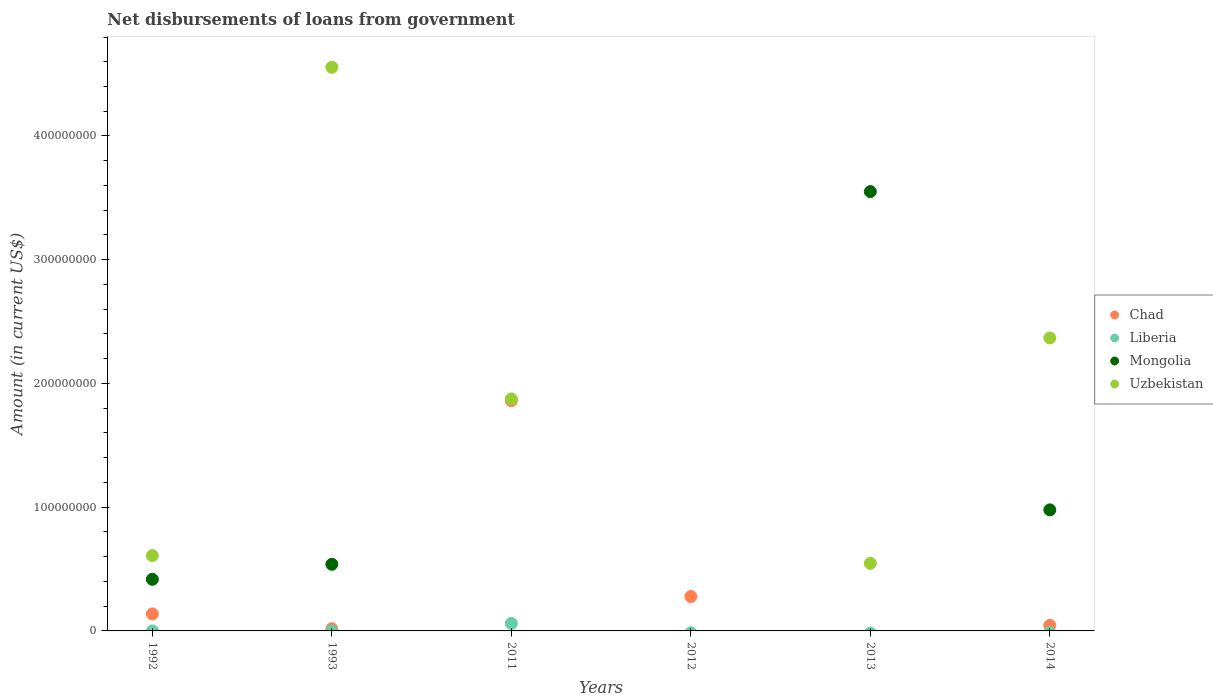Is the number of dotlines equal to the number of legend labels?
Offer a terse response. No. What is the amount of loan disbursed from government in Liberia in 2014?
Your response must be concise. 0. Across all years, what is the maximum amount of loan disbursed from government in Uzbekistan?
Ensure brevity in your answer.  4.56e+08. In which year was the amount of loan disbursed from government in Chad maximum?
Your answer should be compact. 2011. What is the total amount of loan disbursed from government in Uzbekistan in the graph?
Offer a terse response. 9.95e+08. What is the difference between the amount of loan disbursed from government in Uzbekistan in 1993 and that in 2014?
Your answer should be compact. 2.19e+08. What is the difference between the amount of loan disbursed from government in Chad in 1993 and the amount of loan disbursed from government in Liberia in 2013?
Provide a succinct answer. 1.79e+06. What is the average amount of loan disbursed from government in Chad per year?
Offer a very short reply. 3.90e+07. In the year 2013, what is the difference between the amount of loan disbursed from government in Mongolia and amount of loan disbursed from government in Uzbekistan?
Provide a short and direct response. 3.00e+08. What is the ratio of the amount of loan disbursed from government in Uzbekistan in 1993 to that in 2011?
Ensure brevity in your answer.  2.43. What is the difference between the highest and the second highest amount of loan disbursed from government in Mongolia?
Ensure brevity in your answer.  2.57e+08. What is the difference between the highest and the lowest amount of loan disbursed from government in Chad?
Make the answer very short. 1.86e+08. Is the sum of the amount of loan disbursed from government in Uzbekistan in 1992 and 1993 greater than the maximum amount of loan disbursed from government in Chad across all years?
Offer a terse response. Yes. Is it the case that in every year, the sum of the amount of loan disbursed from government in Liberia and amount of loan disbursed from government in Mongolia  is greater than the sum of amount of loan disbursed from government in Chad and amount of loan disbursed from government in Uzbekistan?
Give a very brief answer. No. Is it the case that in every year, the sum of the amount of loan disbursed from government in Chad and amount of loan disbursed from government in Uzbekistan  is greater than the amount of loan disbursed from government in Liberia?
Provide a succinct answer. Yes. Does the amount of loan disbursed from government in Mongolia monotonically increase over the years?
Offer a terse response. No. What is the difference between two consecutive major ticks on the Y-axis?
Make the answer very short. 1.00e+08. Does the graph contain grids?
Keep it short and to the point. No. Where does the legend appear in the graph?
Ensure brevity in your answer.  Center right. How many legend labels are there?
Make the answer very short. 4. How are the legend labels stacked?
Your response must be concise. Vertical. What is the title of the graph?
Make the answer very short. Net disbursements of loans from government. Does "Micronesia" appear as one of the legend labels in the graph?
Make the answer very short. No. What is the label or title of the Y-axis?
Provide a short and direct response. Amount (in current US$). What is the Amount (in current US$) of Chad in 1992?
Your answer should be very brief. 1.37e+07. What is the Amount (in current US$) of Liberia in 1992?
Your answer should be very brief. 2.70e+04. What is the Amount (in current US$) of Mongolia in 1992?
Ensure brevity in your answer.  4.17e+07. What is the Amount (in current US$) of Uzbekistan in 1992?
Ensure brevity in your answer.  6.09e+07. What is the Amount (in current US$) of Chad in 1993?
Your response must be concise. 1.79e+06. What is the Amount (in current US$) of Liberia in 1993?
Your response must be concise. 2.50e+04. What is the Amount (in current US$) in Mongolia in 1993?
Give a very brief answer. 5.38e+07. What is the Amount (in current US$) in Uzbekistan in 1993?
Offer a terse response. 4.56e+08. What is the Amount (in current US$) in Chad in 2011?
Keep it short and to the point. 1.86e+08. What is the Amount (in current US$) in Liberia in 2011?
Your answer should be very brief. 6.04e+06. What is the Amount (in current US$) of Mongolia in 2011?
Keep it short and to the point. 0. What is the Amount (in current US$) of Uzbekistan in 2011?
Provide a succinct answer. 1.87e+08. What is the Amount (in current US$) in Chad in 2012?
Ensure brevity in your answer.  2.78e+07. What is the Amount (in current US$) of Liberia in 2012?
Your answer should be very brief. 0. What is the Amount (in current US$) of Chad in 2013?
Provide a short and direct response. 0. What is the Amount (in current US$) in Liberia in 2013?
Make the answer very short. 0. What is the Amount (in current US$) of Mongolia in 2013?
Offer a terse response. 3.55e+08. What is the Amount (in current US$) of Uzbekistan in 2013?
Keep it short and to the point. 5.46e+07. What is the Amount (in current US$) of Chad in 2014?
Keep it short and to the point. 4.46e+06. What is the Amount (in current US$) in Mongolia in 2014?
Your answer should be compact. 9.79e+07. What is the Amount (in current US$) of Uzbekistan in 2014?
Give a very brief answer. 2.37e+08. Across all years, what is the maximum Amount (in current US$) of Chad?
Offer a very short reply. 1.86e+08. Across all years, what is the maximum Amount (in current US$) in Liberia?
Ensure brevity in your answer.  6.04e+06. Across all years, what is the maximum Amount (in current US$) in Mongolia?
Provide a succinct answer. 3.55e+08. Across all years, what is the maximum Amount (in current US$) in Uzbekistan?
Offer a terse response. 4.56e+08. Across all years, what is the minimum Amount (in current US$) of Chad?
Offer a terse response. 0. Across all years, what is the minimum Amount (in current US$) in Mongolia?
Your answer should be very brief. 0. Across all years, what is the minimum Amount (in current US$) of Uzbekistan?
Your response must be concise. 0. What is the total Amount (in current US$) in Chad in the graph?
Provide a short and direct response. 2.34e+08. What is the total Amount (in current US$) in Liberia in the graph?
Provide a succinct answer. 6.09e+06. What is the total Amount (in current US$) in Mongolia in the graph?
Your response must be concise. 5.48e+08. What is the total Amount (in current US$) of Uzbekistan in the graph?
Your answer should be compact. 9.95e+08. What is the difference between the Amount (in current US$) of Chad in 1992 and that in 1993?
Ensure brevity in your answer.  1.20e+07. What is the difference between the Amount (in current US$) in Liberia in 1992 and that in 1993?
Offer a terse response. 2000. What is the difference between the Amount (in current US$) in Mongolia in 1992 and that in 1993?
Your answer should be compact. -1.21e+07. What is the difference between the Amount (in current US$) of Uzbekistan in 1992 and that in 1993?
Offer a terse response. -3.95e+08. What is the difference between the Amount (in current US$) of Chad in 1992 and that in 2011?
Ensure brevity in your answer.  -1.72e+08. What is the difference between the Amount (in current US$) of Liberia in 1992 and that in 2011?
Ensure brevity in your answer.  -6.01e+06. What is the difference between the Amount (in current US$) of Uzbekistan in 1992 and that in 2011?
Your answer should be compact. -1.27e+08. What is the difference between the Amount (in current US$) of Chad in 1992 and that in 2012?
Provide a short and direct response. -1.40e+07. What is the difference between the Amount (in current US$) of Mongolia in 1992 and that in 2013?
Your answer should be very brief. -3.13e+08. What is the difference between the Amount (in current US$) in Uzbekistan in 1992 and that in 2013?
Make the answer very short. 6.28e+06. What is the difference between the Amount (in current US$) of Chad in 1992 and that in 2014?
Your answer should be very brief. 9.28e+06. What is the difference between the Amount (in current US$) of Mongolia in 1992 and that in 2014?
Offer a terse response. -5.61e+07. What is the difference between the Amount (in current US$) in Uzbekistan in 1992 and that in 2014?
Make the answer very short. -1.76e+08. What is the difference between the Amount (in current US$) of Chad in 1993 and that in 2011?
Offer a terse response. -1.84e+08. What is the difference between the Amount (in current US$) in Liberia in 1993 and that in 2011?
Keep it short and to the point. -6.02e+06. What is the difference between the Amount (in current US$) of Uzbekistan in 1993 and that in 2011?
Your response must be concise. 2.68e+08. What is the difference between the Amount (in current US$) of Chad in 1993 and that in 2012?
Make the answer very short. -2.60e+07. What is the difference between the Amount (in current US$) in Mongolia in 1993 and that in 2013?
Ensure brevity in your answer.  -3.01e+08. What is the difference between the Amount (in current US$) in Uzbekistan in 1993 and that in 2013?
Provide a succinct answer. 4.01e+08. What is the difference between the Amount (in current US$) in Chad in 1993 and that in 2014?
Offer a very short reply. -2.68e+06. What is the difference between the Amount (in current US$) of Mongolia in 1993 and that in 2014?
Give a very brief answer. -4.40e+07. What is the difference between the Amount (in current US$) in Uzbekistan in 1993 and that in 2014?
Provide a short and direct response. 2.19e+08. What is the difference between the Amount (in current US$) in Chad in 2011 and that in 2012?
Make the answer very short. 1.58e+08. What is the difference between the Amount (in current US$) of Uzbekistan in 2011 and that in 2013?
Make the answer very short. 1.33e+08. What is the difference between the Amount (in current US$) of Chad in 2011 and that in 2014?
Offer a very short reply. 1.82e+08. What is the difference between the Amount (in current US$) in Uzbekistan in 2011 and that in 2014?
Ensure brevity in your answer.  -4.93e+07. What is the difference between the Amount (in current US$) of Chad in 2012 and that in 2014?
Your answer should be very brief. 2.33e+07. What is the difference between the Amount (in current US$) in Mongolia in 2013 and that in 2014?
Ensure brevity in your answer.  2.57e+08. What is the difference between the Amount (in current US$) of Uzbekistan in 2013 and that in 2014?
Offer a terse response. -1.82e+08. What is the difference between the Amount (in current US$) in Chad in 1992 and the Amount (in current US$) in Liberia in 1993?
Offer a very short reply. 1.37e+07. What is the difference between the Amount (in current US$) of Chad in 1992 and the Amount (in current US$) of Mongolia in 1993?
Give a very brief answer. -4.01e+07. What is the difference between the Amount (in current US$) in Chad in 1992 and the Amount (in current US$) in Uzbekistan in 1993?
Provide a short and direct response. -4.42e+08. What is the difference between the Amount (in current US$) in Liberia in 1992 and the Amount (in current US$) in Mongolia in 1993?
Offer a terse response. -5.38e+07. What is the difference between the Amount (in current US$) of Liberia in 1992 and the Amount (in current US$) of Uzbekistan in 1993?
Keep it short and to the point. -4.56e+08. What is the difference between the Amount (in current US$) of Mongolia in 1992 and the Amount (in current US$) of Uzbekistan in 1993?
Your answer should be compact. -4.14e+08. What is the difference between the Amount (in current US$) of Chad in 1992 and the Amount (in current US$) of Liberia in 2011?
Offer a very short reply. 7.71e+06. What is the difference between the Amount (in current US$) in Chad in 1992 and the Amount (in current US$) in Uzbekistan in 2011?
Your response must be concise. -1.74e+08. What is the difference between the Amount (in current US$) in Liberia in 1992 and the Amount (in current US$) in Uzbekistan in 2011?
Your answer should be very brief. -1.87e+08. What is the difference between the Amount (in current US$) of Mongolia in 1992 and the Amount (in current US$) of Uzbekistan in 2011?
Keep it short and to the point. -1.46e+08. What is the difference between the Amount (in current US$) in Chad in 1992 and the Amount (in current US$) in Mongolia in 2013?
Your answer should be very brief. -3.41e+08. What is the difference between the Amount (in current US$) of Chad in 1992 and the Amount (in current US$) of Uzbekistan in 2013?
Your answer should be compact. -4.09e+07. What is the difference between the Amount (in current US$) in Liberia in 1992 and the Amount (in current US$) in Mongolia in 2013?
Your answer should be very brief. -3.55e+08. What is the difference between the Amount (in current US$) in Liberia in 1992 and the Amount (in current US$) in Uzbekistan in 2013?
Your answer should be very brief. -5.46e+07. What is the difference between the Amount (in current US$) of Mongolia in 1992 and the Amount (in current US$) of Uzbekistan in 2013?
Make the answer very short. -1.29e+07. What is the difference between the Amount (in current US$) in Chad in 1992 and the Amount (in current US$) in Mongolia in 2014?
Offer a very short reply. -8.41e+07. What is the difference between the Amount (in current US$) in Chad in 1992 and the Amount (in current US$) in Uzbekistan in 2014?
Provide a short and direct response. -2.23e+08. What is the difference between the Amount (in current US$) of Liberia in 1992 and the Amount (in current US$) of Mongolia in 2014?
Ensure brevity in your answer.  -9.78e+07. What is the difference between the Amount (in current US$) in Liberia in 1992 and the Amount (in current US$) in Uzbekistan in 2014?
Keep it short and to the point. -2.37e+08. What is the difference between the Amount (in current US$) in Mongolia in 1992 and the Amount (in current US$) in Uzbekistan in 2014?
Your response must be concise. -1.95e+08. What is the difference between the Amount (in current US$) in Chad in 1993 and the Amount (in current US$) in Liberia in 2011?
Provide a succinct answer. -4.25e+06. What is the difference between the Amount (in current US$) of Chad in 1993 and the Amount (in current US$) of Uzbekistan in 2011?
Ensure brevity in your answer.  -1.86e+08. What is the difference between the Amount (in current US$) of Liberia in 1993 and the Amount (in current US$) of Uzbekistan in 2011?
Your response must be concise. -1.87e+08. What is the difference between the Amount (in current US$) in Mongolia in 1993 and the Amount (in current US$) in Uzbekistan in 2011?
Offer a terse response. -1.34e+08. What is the difference between the Amount (in current US$) in Chad in 1993 and the Amount (in current US$) in Mongolia in 2013?
Provide a succinct answer. -3.53e+08. What is the difference between the Amount (in current US$) in Chad in 1993 and the Amount (in current US$) in Uzbekistan in 2013?
Ensure brevity in your answer.  -5.28e+07. What is the difference between the Amount (in current US$) of Liberia in 1993 and the Amount (in current US$) of Mongolia in 2013?
Offer a very short reply. -3.55e+08. What is the difference between the Amount (in current US$) of Liberia in 1993 and the Amount (in current US$) of Uzbekistan in 2013?
Your answer should be very brief. -5.46e+07. What is the difference between the Amount (in current US$) of Mongolia in 1993 and the Amount (in current US$) of Uzbekistan in 2013?
Keep it short and to the point. -7.75e+05. What is the difference between the Amount (in current US$) of Chad in 1993 and the Amount (in current US$) of Mongolia in 2014?
Give a very brief answer. -9.61e+07. What is the difference between the Amount (in current US$) of Chad in 1993 and the Amount (in current US$) of Uzbekistan in 2014?
Your answer should be very brief. -2.35e+08. What is the difference between the Amount (in current US$) in Liberia in 1993 and the Amount (in current US$) in Mongolia in 2014?
Offer a terse response. -9.78e+07. What is the difference between the Amount (in current US$) in Liberia in 1993 and the Amount (in current US$) in Uzbekistan in 2014?
Give a very brief answer. -2.37e+08. What is the difference between the Amount (in current US$) of Mongolia in 1993 and the Amount (in current US$) of Uzbekistan in 2014?
Make the answer very short. -1.83e+08. What is the difference between the Amount (in current US$) of Chad in 2011 and the Amount (in current US$) of Mongolia in 2013?
Your answer should be compact. -1.69e+08. What is the difference between the Amount (in current US$) of Chad in 2011 and the Amount (in current US$) of Uzbekistan in 2013?
Provide a succinct answer. 1.31e+08. What is the difference between the Amount (in current US$) of Liberia in 2011 and the Amount (in current US$) of Mongolia in 2013?
Your answer should be compact. -3.49e+08. What is the difference between the Amount (in current US$) in Liberia in 2011 and the Amount (in current US$) in Uzbekistan in 2013?
Ensure brevity in your answer.  -4.86e+07. What is the difference between the Amount (in current US$) of Chad in 2011 and the Amount (in current US$) of Mongolia in 2014?
Ensure brevity in your answer.  8.82e+07. What is the difference between the Amount (in current US$) in Chad in 2011 and the Amount (in current US$) in Uzbekistan in 2014?
Give a very brief answer. -5.08e+07. What is the difference between the Amount (in current US$) of Liberia in 2011 and the Amount (in current US$) of Mongolia in 2014?
Your answer should be very brief. -9.18e+07. What is the difference between the Amount (in current US$) of Liberia in 2011 and the Amount (in current US$) of Uzbekistan in 2014?
Make the answer very short. -2.31e+08. What is the difference between the Amount (in current US$) of Chad in 2012 and the Amount (in current US$) of Mongolia in 2013?
Your response must be concise. -3.27e+08. What is the difference between the Amount (in current US$) of Chad in 2012 and the Amount (in current US$) of Uzbekistan in 2013?
Provide a short and direct response. -2.68e+07. What is the difference between the Amount (in current US$) in Chad in 2012 and the Amount (in current US$) in Mongolia in 2014?
Keep it short and to the point. -7.01e+07. What is the difference between the Amount (in current US$) in Chad in 2012 and the Amount (in current US$) in Uzbekistan in 2014?
Your answer should be very brief. -2.09e+08. What is the difference between the Amount (in current US$) in Mongolia in 2013 and the Amount (in current US$) in Uzbekistan in 2014?
Your answer should be compact. 1.18e+08. What is the average Amount (in current US$) in Chad per year?
Keep it short and to the point. 3.90e+07. What is the average Amount (in current US$) in Liberia per year?
Ensure brevity in your answer.  1.02e+06. What is the average Amount (in current US$) of Mongolia per year?
Keep it short and to the point. 9.14e+07. What is the average Amount (in current US$) of Uzbekistan per year?
Keep it short and to the point. 1.66e+08. In the year 1992, what is the difference between the Amount (in current US$) in Chad and Amount (in current US$) in Liberia?
Offer a very short reply. 1.37e+07. In the year 1992, what is the difference between the Amount (in current US$) of Chad and Amount (in current US$) of Mongolia?
Your response must be concise. -2.80e+07. In the year 1992, what is the difference between the Amount (in current US$) in Chad and Amount (in current US$) in Uzbekistan?
Ensure brevity in your answer.  -4.71e+07. In the year 1992, what is the difference between the Amount (in current US$) in Liberia and Amount (in current US$) in Mongolia?
Give a very brief answer. -4.17e+07. In the year 1992, what is the difference between the Amount (in current US$) in Liberia and Amount (in current US$) in Uzbekistan?
Keep it short and to the point. -6.09e+07. In the year 1992, what is the difference between the Amount (in current US$) of Mongolia and Amount (in current US$) of Uzbekistan?
Provide a short and direct response. -1.92e+07. In the year 1993, what is the difference between the Amount (in current US$) in Chad and Amount (in current US$) in Liberia?
Your response must be concise. 1.76e+06. In the year 1993, what is the difference between the Amount (in current US$) of Chad and Amount (in current US$) of Mongolia?
Keep it short and to the point. -5.21e+07. In the year 1993, what is the difference between the Amount (in current US$) in Chad and Amount (in current US$) in Uzbekistan?
Keep it short and to the point. -4.54e+08. In the year 1993, what is the difference between the Amount (in current US$) in Liberia and Amount (in current US$) in Mongolia?
Your answer should be compact. -5.38e+07. In the year 1993, what is the difference between the Amount (in current US$) of Liberia and Amount (in current US$) of Uzbekistan?
Ensure brevity in your answer.  -4.56e+08. In the year 1993, what is the difference between the Amount (in current US$) of Mongolia and Amount (in current US$) of Uzbekistan?
Give a very brief answer. -4.02e+08. In the year 2011, what is the difference between the Amount (in current US$) of Chad and Amount (in current US$) of Liberia?
Ensure brevity in your answer.  1.80e+08. In the year 2011, what is the difference between the Amount (in current US$) in Chad and Amount (in current US$) in Uzbekistan?
Offer a very short reply. -1.42e+06. In the year 2011, what is the difference between the Amount (in current US$) in Liberia and Amount (in current US$) in Uzbekistan?
Offer a very short reply. -1.81e+08. In the year 2013, what is the difference between the Amount (in current US$) in Mongolia and Amount (in current US$) in Uzbekistan?
Your answer should be very brief. 3.00e+08. In the year 2014, what is the difference between the Amount (in current US$) of Chad and Amount (in current US$) of Mongolia?
Keep it short and to the point. -9.34e+07. In the year 2014, what is the difference between the Amount (in current US$) in Chad and Amount (in current US$) in Uzbekistan?
Ensure brevity in your answer.  -2.32e+08. In the year 2014, what is the difference between the Amount (in current US$) in Mongolia and Amount (in current US$) in Uzbekistan?
Your response must be concise. -1.39e+08. What is the ratio of the Amount (in current US$) in Chad in 1992 to that in 1993?
Provide a succinct answer. 7.69. What is the ratio of the Amount (in current US$) in Liberia in 1992 to that in 1993?
Your answer should be very brief. 1.08. What is the ratio of the Amount (in current US$) of Mongolia in 1992 to that in 1993?
Make the answer very short. 0.77. What is the ratio of the Amount (in current US$) of Uzbekistan in 1992 to that in 1993?
Your response must be concise. 0.13. What is the ratio of the Amount (in current US$) in Chad in 1992 to that in 2011?
Your response must be concise. 0.07. What is the ratio of the Amount (in current US$) of Liberia in 1992 to that in 2011?
Your answer should be very brief. 0. What is the ratio of the Amount (in current US$) of Uzbekistan in 1992 to that in 2011?
Provide a short and direct response. 0.32. What is the ratio of the Amount (in current US$) in Chad in 1992 to that in 2012?
Give a very brief answer. 0.49. What is the ratio of the Amount (in current US$) in Mongolia in 1992 to that in 2013?
Keep it short and to the point. 0.12. What is the ratio of the Amount (in current US$) in Uzbekistan in 1992 to that in 2013?
Offer a very short reply. 1.11. What is the ratio of the Amount (in current US$) of Chad in 1992 to that in 2014?
Provide a succinct answer. 3.08. What is the ratio of the Amount (in current US$) of Mongolia in 1992 to that in 2014?
Provide a short and direct response. 0.43. What is the ratio of the Amount (in current US$) of Uzbekistan in 1992 to that in 2014?
Provide a short and direct response. 0.26. What is the ratio of the Amount (in current US$) in Chad in 1993 to that in 2011?
Your answer should be very brief. 0.01. What is the ratio of the Amount (in current US$) in Liberia in 1993 to that in 2011?
Keep it short and to the point. 0. What is the ratio of the Amount (in current US$) of Uzbekistan in 1993 to that in 2011?
Give a very brief answer. 2.43. What is the ratio of the Amount (in current US$) in Chad in 1993 to that in 2012?
Make the answer very short. 0.06. What is the ratio of the Amount (in current US$) of Mongolia in 1993 to that in 2013?
Offer a very short reply. 0.15. What is the ratio of the Amount (in current US$) in Uzbekistan in 1993 to that in 2013?
Give a very brief answer. 8.34. What is the ratio of the Amount (in current US$) in Chad in 1993 to that in 2014?
Ensure brevity in your answer.  0.4. What is the ratio of the Amount (in current US$) of Mongolia in 1993 to that in 2014?
Your response must be concise. 0.55. What is the ratio of the Amount (in current US$) in Uzbekistan in 1993 to that in 2014?
Your answer should be very brief. 1.92. What is the ratio of the Amount (in current US$) of Chad in 2011 to that in 2012?
Provide a succinct answer. 6.69. What is the ratio of the Amount (in current US$) in Uzbekistan in 2011 to that in 2013?
Make the answer very short. 3.43. What is the ratio of the Amount (in current US$) of Chad in 2011 to that in 2014?
Your answer should be very brief. 41.67. What is the ratio of the Amount (in current US$) of Uzbekistan in 2011 to that in 2014?
Ensure brevity in your answer.  0.79. What is the ratio of the Amount (in current US$) of Chad in 2012 to that in 2014?
Your answer should be very brief. 6.22. What is the ratio of the Amount (in current US$) of Mongolia in 2013 to that in 2014?
Provide a succinct answer. 3.63. What is the ratio of the Amount (in current US$) in Uzbekistan in 2013 to that in 2014?
Your answer should be very brief. 0.23. What is the difference between the highest and the second highest Amount (in current US$) of Chad?
Provide a short and direct response. 1.58e+08. What is the difference between the highest and the second highest Amount (in current US$) in Liberia?
Give a very brief answer. 6.01e+06. What is the difference between the highest and the second highest Amount (in current US$) of Mongolia?
Offer a very short reply. 2.57e+08. What is the difference between the highest and the second highest Amount (in current US$) in Uzbekistan?
Offer a very short reply. 2.19e+08. What is the difference between the highest and the lowest Amount (in current US$) in Chad?
Provide a succinct answer. 1.86e+08. What is the difference between the highest and the lowest Amount (in current US$) in Liberia?
Offer a terse response. 6.04e+06. What is the difference between the highest and the lowest Amount (in current US$) of Mongolia?
Offer a terse response. 3.55e+08. What is the difference between the highest and the lowest Amount (in current US$) in Uzbekistan?
Make the answer very short. 4.56e+08. 